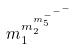<formula> <loc_0><loc_0><loc_500><loc_500>m _ { 1 } ^ { m _ { 2 } ^ { m _ { 5 } ^ { - ^ { - ^ { - } } } } }</formula> 